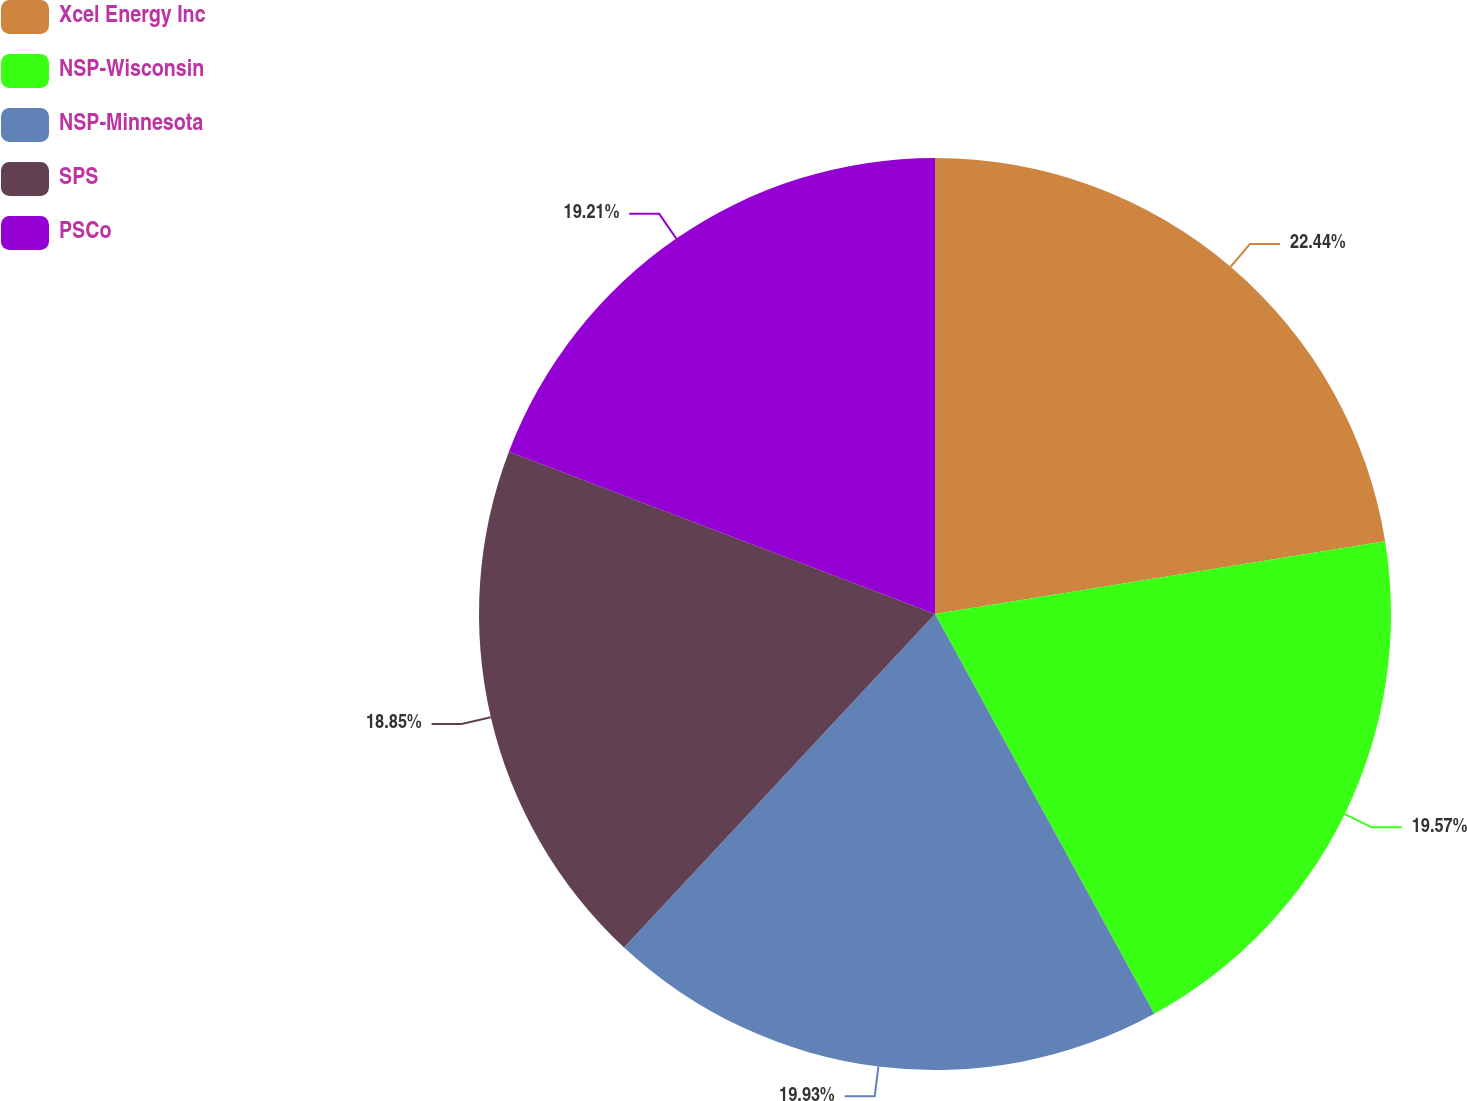Convert chart to OTSL. <chart><loc_0><loc_0><loc_500><loc_500><pie_chart><fcel>Xcel Energy Inc<fcel>NSP-Wisconsin<fcel>NSP-Minnesota<fcel>SPS<fcel>PSCo<nl><fcel>22.45%<fcel>19.57%<fcel>19.93%<fcel>18.85%<fcel>19.21%<nl></chart> 